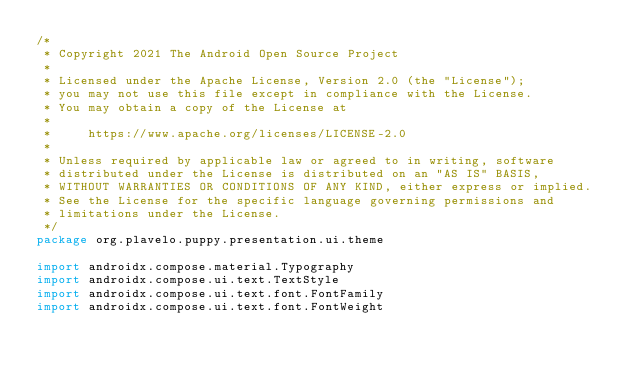<code> <loc_0><loc_0><loc_500><loc_500><_Kotlin_>/*
 * Copyright 2021 The Android Open Source Project
 *
 * Licensed under the Apache License, Version 2.0 (the "License");
 * you may not use this file except in compliance with the License.
 * You may obtain a copy of the License at
 *
 *     https://www.apache.org/licenses/LICENSE-2.0
 *
 * Unless required by applicable law or agreed to in writing, software
 * distributed under the License is distributed on an "AS IS" BASIS,
 * WITHOUT WARRANTIES OR CONDITIONS OF ANY KIND, either express or implied.
 * See the License for the specific language governing permissions and
 * limitations under the License.
 */
package org.plavelo.puppy.presentation.ui.theme

import androidx.compose.material.Typography
import androidx.compose.ui.text.TextStyle
import androidx.compose.ui.text.font.FontFamily
import androidx.compose.ui.text.font.FontWeight</code> 